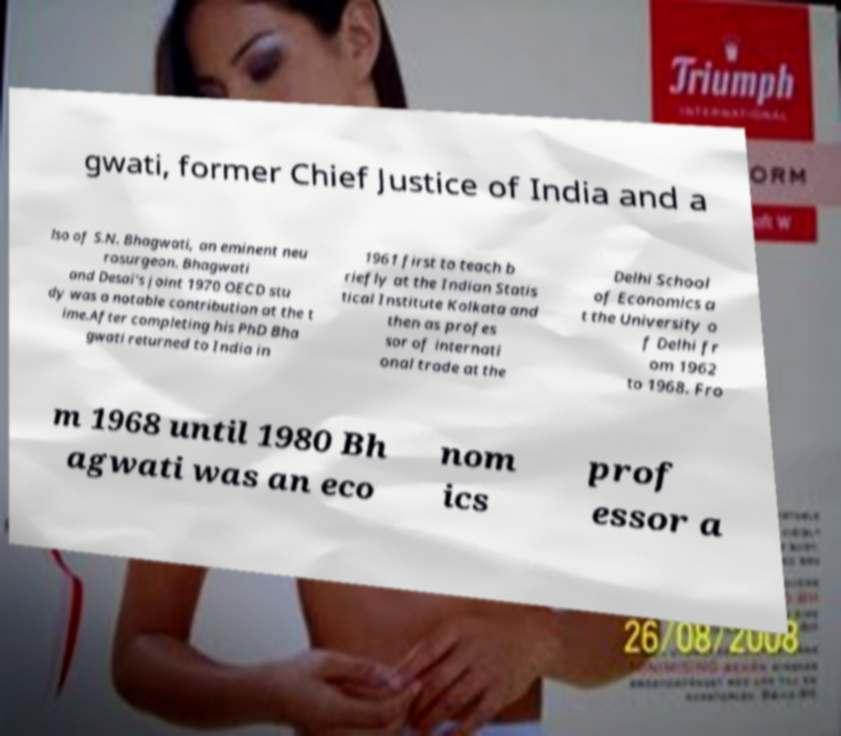There's text embedded in this image that I need extracted. Can you transcribe it verbatim? gwati, former Chief Justice of India and a lso of S.N. Bhagwati, an eminent neu rosurgeon. Bhagwati and Desai's joint 1970 OECD stu dy was a notable contribution at the t ime.After completing his PhD Bha gwati returned to India in 1961 first to teach b riefly at the Indian Statis tical Institute Kolkata and then as profes sor of internati onal trade at the Delhi School of Economics a t the University o f Delhi fr om 1962 to 1968. Fro m 1968 until 1980 Bh agwati was an eco nom ics prof essor a 